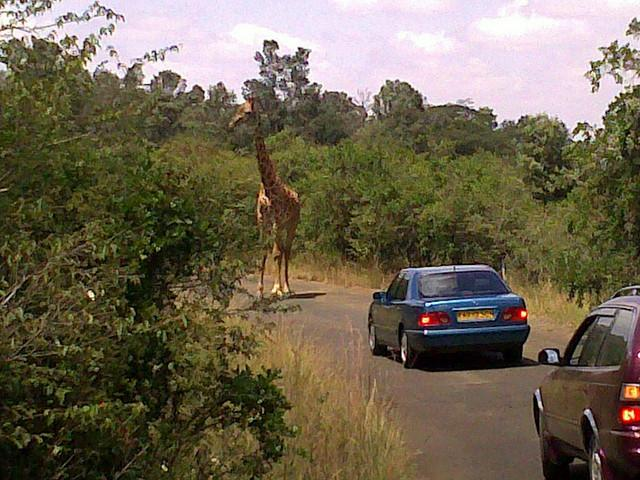What are you supposed to do when you meet an animal like this on the road? Please explain your reasoning. stop. Stop so you don't hurt them. 